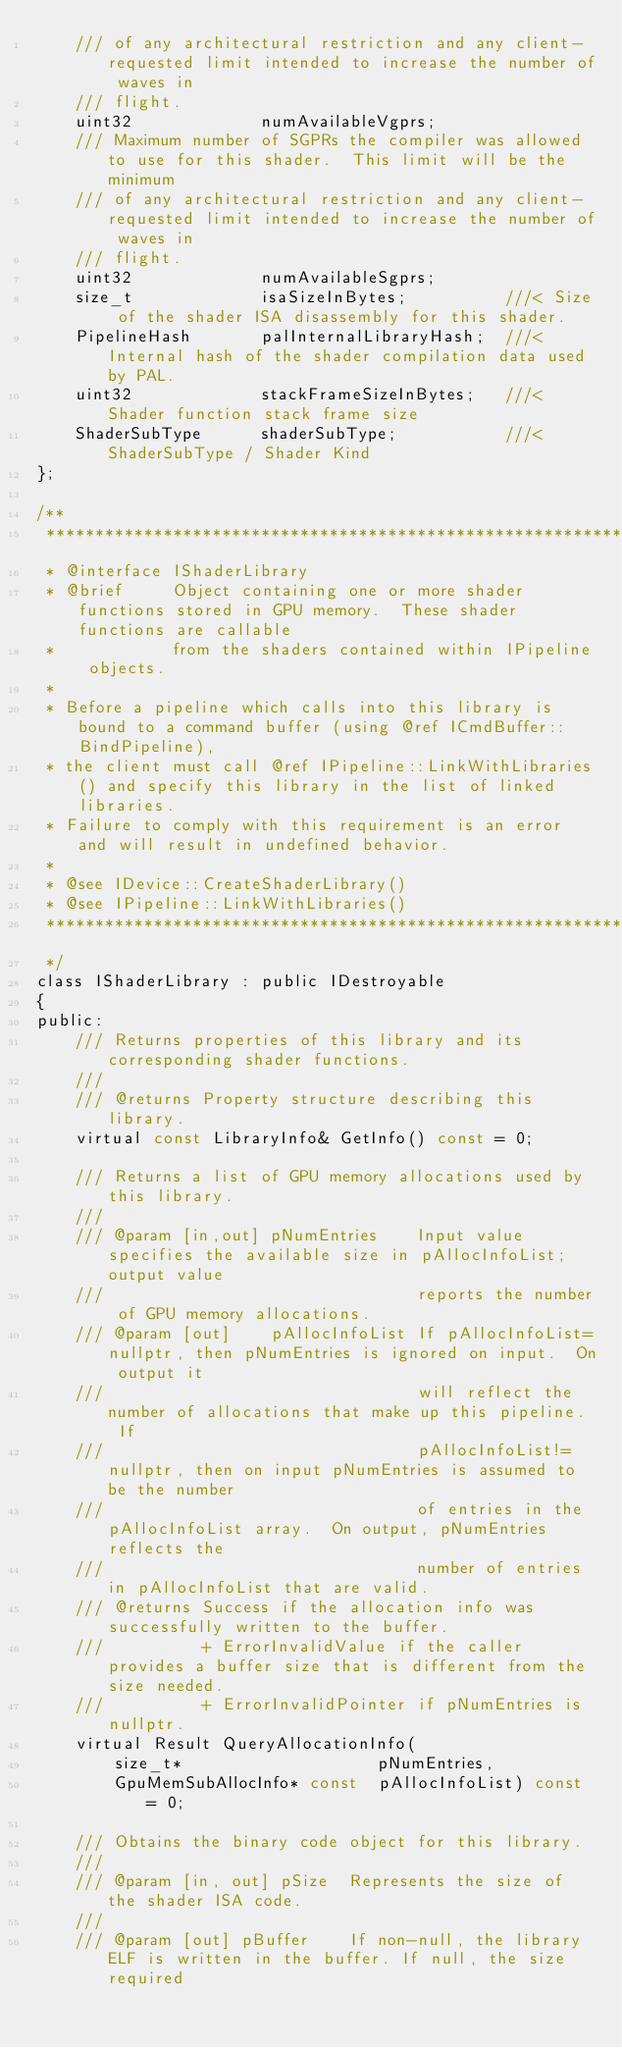<code> <loc_0><loc_0><loc_500><loc_500><_C_>    /// of any architectural restriction and any client-requested limit intended to increase the number of waves in
    /// flight.
    uint32             numAvailableVgprs;
    /// Maximum number of SGPRs the compiler was allowed to use for this shader.  This limit will be the minimum
    /// of any architectural restriction and any client-requested limit intended to increase the number of waves in
    /// flight.
    uint32             numAvailableSgprs;
    size_t             isaSizeInBytes;          ///< Size of the shader ISA disassembly for this shader.
    PipelineHash       palInternalLibraryHash;  ///< Internal hash of the shader compilation data used by PAL.
    uint32             stackFrameSizeInBytes;   ///< Shader function stack frame size
    ShaderSubType      shaderSubType;           ///< ShaderSubType / Shader Kind
};

/**
 ***********************************************************************************************************************
 * @interface IShaderLibrary
 * @brief     Object containing one or more shader functions stored in GPU memory.  These shader functions are callable
 *            from the shaders contained within IPipeline objects.
 *
 * Before a pipeline which calls into this library is bound to a command buffer (using @ref ICmdBuffer::BindPipeline),
 * the client must call @ref IPipeline::LinkWithLibraries() and specify this library in the list of linked libraries.
 * Failure to comply with this requirement is an error and will result in undefined behavior.
 *
 * @see IDevice::CreateShaderLibrary()
 * @see IPipeline::LinkWithLibraries()
 ***********************************************************************************************************************
 */
class IShaderLibrary : public IDestroyable
{
public:
    /// Returns properties of this library and its corresponding shader functions.
    ///
    /// @returns Property structure describing this library.
    virtual const LibraryInfo& GetInfo() const = 0;

    /// Returns a list of GPU memory allocations used by this library.
    ///
    /// @param [in,out] pNumEntries    Input value specifies the available size in pAllocInfoList; output value
    ///                                reports the number of GPU memory allocations.
    /// @param [out]    pAllocInfoList If pAllocInfoList=nullptr, then pNumEntries is ignored on input.  On output it
    ///                                will reflect the number of allocations that make up this pipeline.  If
    ///                                pAllocInfoList!=nullptr, then on input pNumEntries is assumed to be the number
    ///                                of entries in the pAllocInfoList array.  On output, pNumEntries reflects the
    ///                                number of entries in pAllocInfoList that are valid.
    /// @returns Success if the allocation info was successfully written to the buffer.
    ///          + ErrorInvalidValue if the caller provides a buffer size that is different from the size needed.
    ///          + ErrorInvalidPointer if pNumEntries is nullptr.
    virtual Result QueryAllocationInfo(
        size_t*                    pNumEntries,
        GpuMemSubAllocInfo* const  pAllocInfoList) const = 0;

    /// Obtains the binary code object for this library.
    ///
    /// @param [in, out] pSize  Represents the size of the shader ISA code.
    ///
    /// @param [out] pBuffer    If non-null, the library ELF is written in the buffer. If null, the size required</code> 